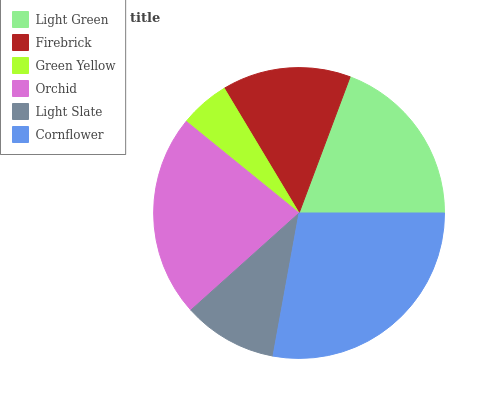Is Green Yellow the minimum?
Answer yes or no. Yes. Is Cornflower the maximum?
Answer yes or no. Yes. Is Firebrick the minimum?
Answer yes or no. No. Is Firebrick the maximum?
Answer yes or no. No. Is Light Green greater than Firebrick?
Answer yes or no. Yes. Is Firebrick less than Light Green?
Answer yes or no. Yes. Is Firebrick greater than Light Green?
Answer yes or no. No. Is Light Green less than Firebrick?
Answer yes or no. No. Is Light Green the high median?
Answer yes or no. Yes. Is Firebrick the low median?
Answer yes or no. Yes. Is Cornflower the high median?
Answer yes or no. No. Is Light Slate the low median?
Answer yes or no. No. 